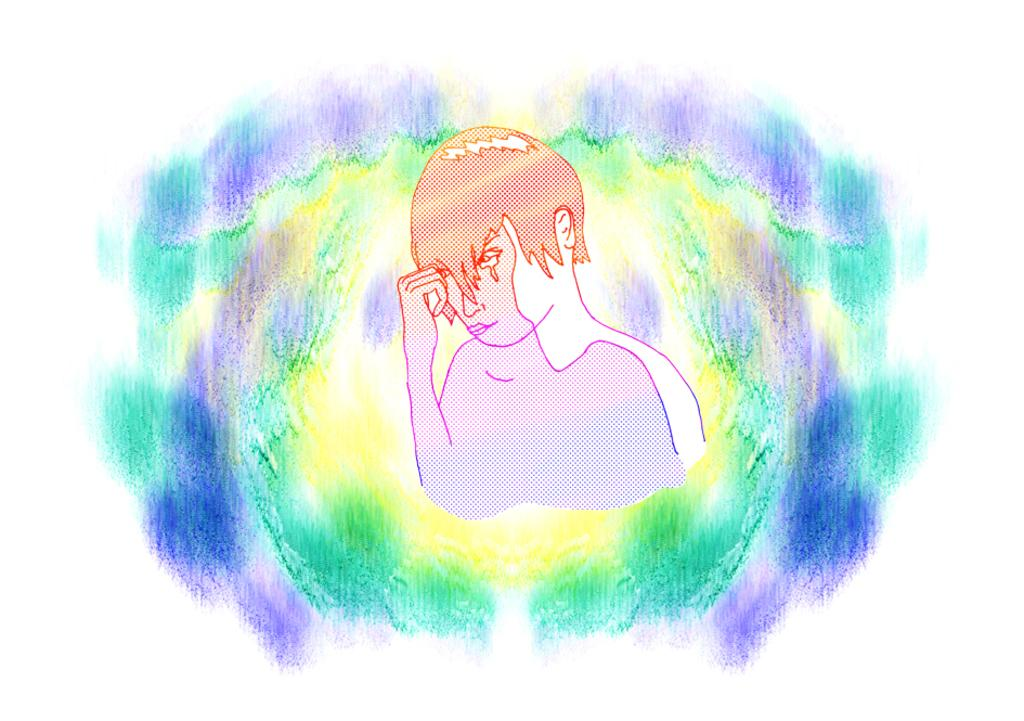What type of artwork is depicted in the image? The image is a painting. What is the main subject of the painting? There is an image of a person in the painting. What type of digestion system does the person in the painting have? The painting does not provide information about the person's digestion system, as it is a visual representation and not a detailed description of the person's anatomy. 